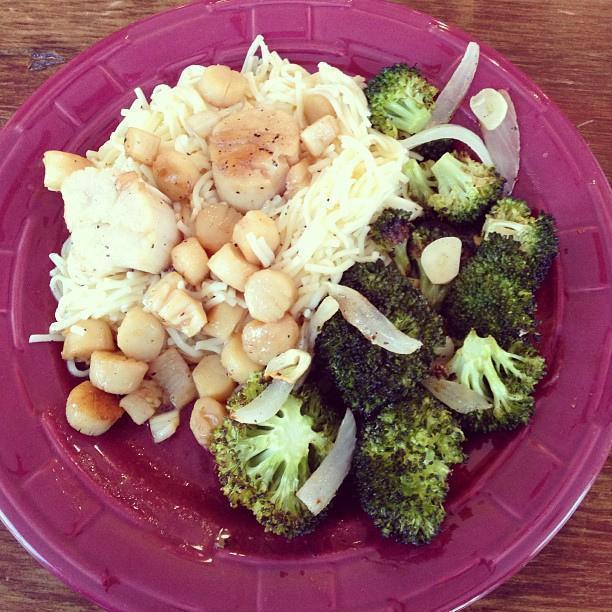What type of seafood is being served?
From the following four choices, select the correct answer to address the question.
Options: Scallops, shrimp, crab, fish. Scallops. 